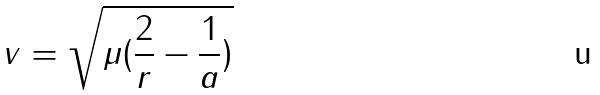<formula> <loc_0><loc_0><loc_500><loc_500>v = \sqrt { \mu ( \frac { 2 } { r } - \frac { 1 } { a } ) }</formula> 